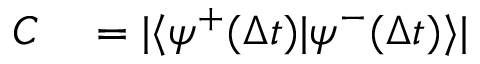<formula> <loc_0><loc_0><loc_500><loc_500>\begin{array} { r l } { C } & = | \langle \psi ^ { + } ( \Delta t ) | \psi ^ { - } ( \Delta t ) \rangle | } \end{array}</formula> 